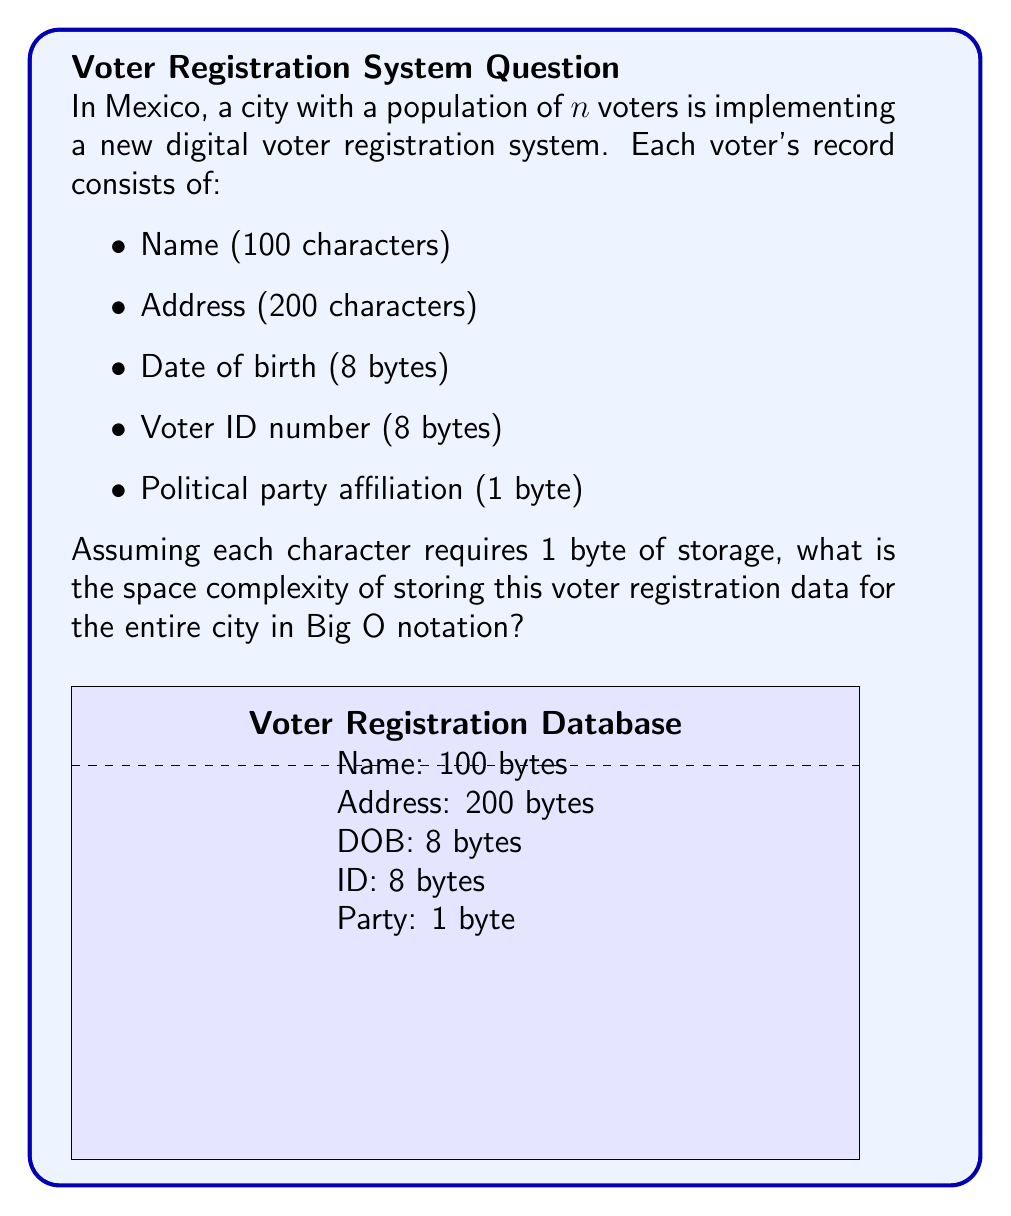Solve this math problem. Let's approach this step-by-step:

1) First, we need to calculate the total number of bytes required for each voter's record:
   - Name: 100 bytes
   - Address: 200 bytes
   - Date of birth: 8 bytes
   - Voter ID number: 8 bytes
   - Political party affiliation: 1 byte
   
   Total = 100 + 200 + 8 + 8 + 1 = 317 bytes per voter

2) Now, we need to consider the total number of voters, which is given as $n$.

3) The total space required for all voters will be:
   $317n$ bytes

4) In Big O notation, we ignore constant factors. The space complexity is determined by how the storage requirements grow with respect to $n$.

5) Since the storage grows linearly with $n$, we can express the space complexity as $O(n)$.

6) It's worth noting that while the actual storage is $317n$ bytes, in Big O notation we simplify this to $O(n)$ because we're interested in the growth rate, not the exact number of bytes.
Answer: $O(n)$ 